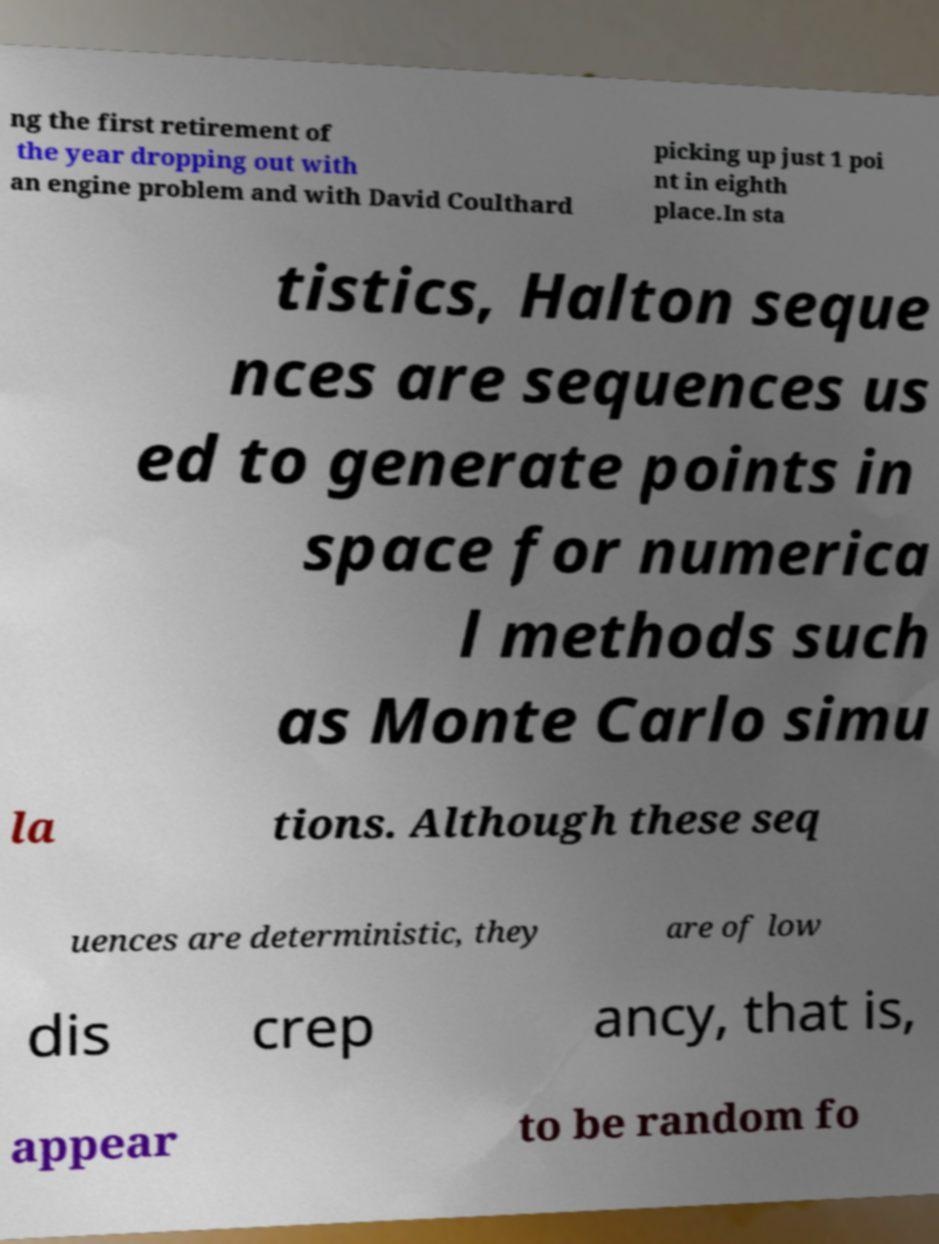Can you accurately transcribe the text from the provided image for me? ng the first retirement of the year dropping out with an engine problem and with David Coulthard picking up just 1 poi nt in eighth place.In sta tistics, Halton seque nces are sequences us ed to generate points in space for numerica l methods such as Monte Carlo simu la tions. Although these seq uences are deterministic, they are of low dis crep ancy, that is, appear to be random fo 